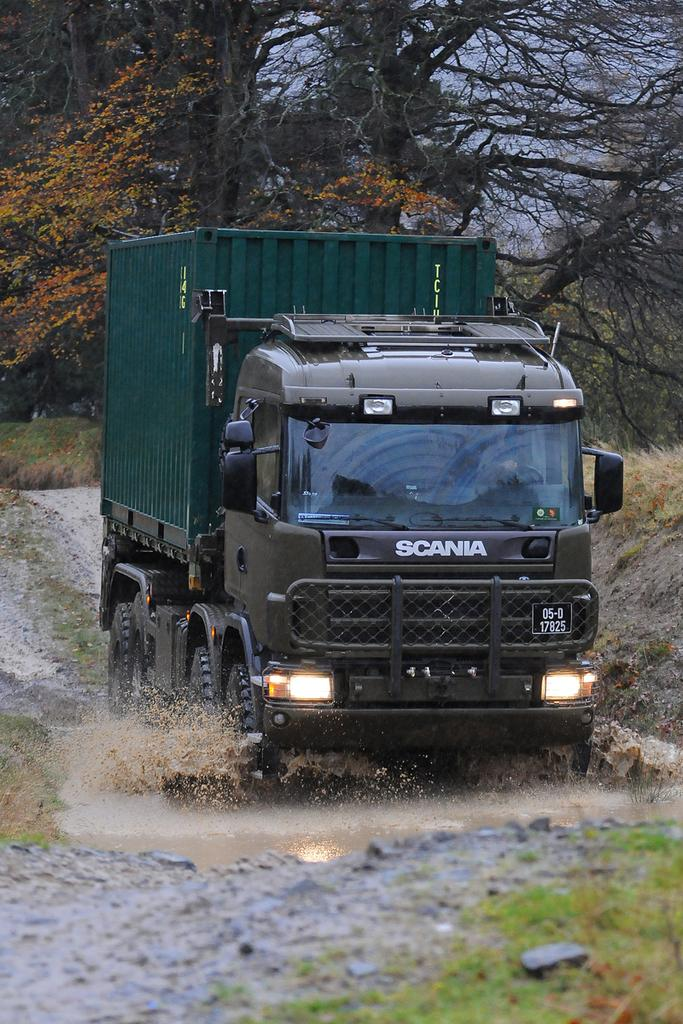What is the main subject of the image? The main subject of the image is a truck. What is the truck doing in the image? The truck is moving in the water. What can be seen on the back of the truck? There are trees visible on the back of the truck. What colors are used to paint the truck? The truck is black and green in color. How many ladybugs can be seen on the truck in the image? There are no ladybugs present on the truck in the image. What type of support system is used to keep the truck afloat in the water? The image does not provide information about a support system for the truck in the water. 